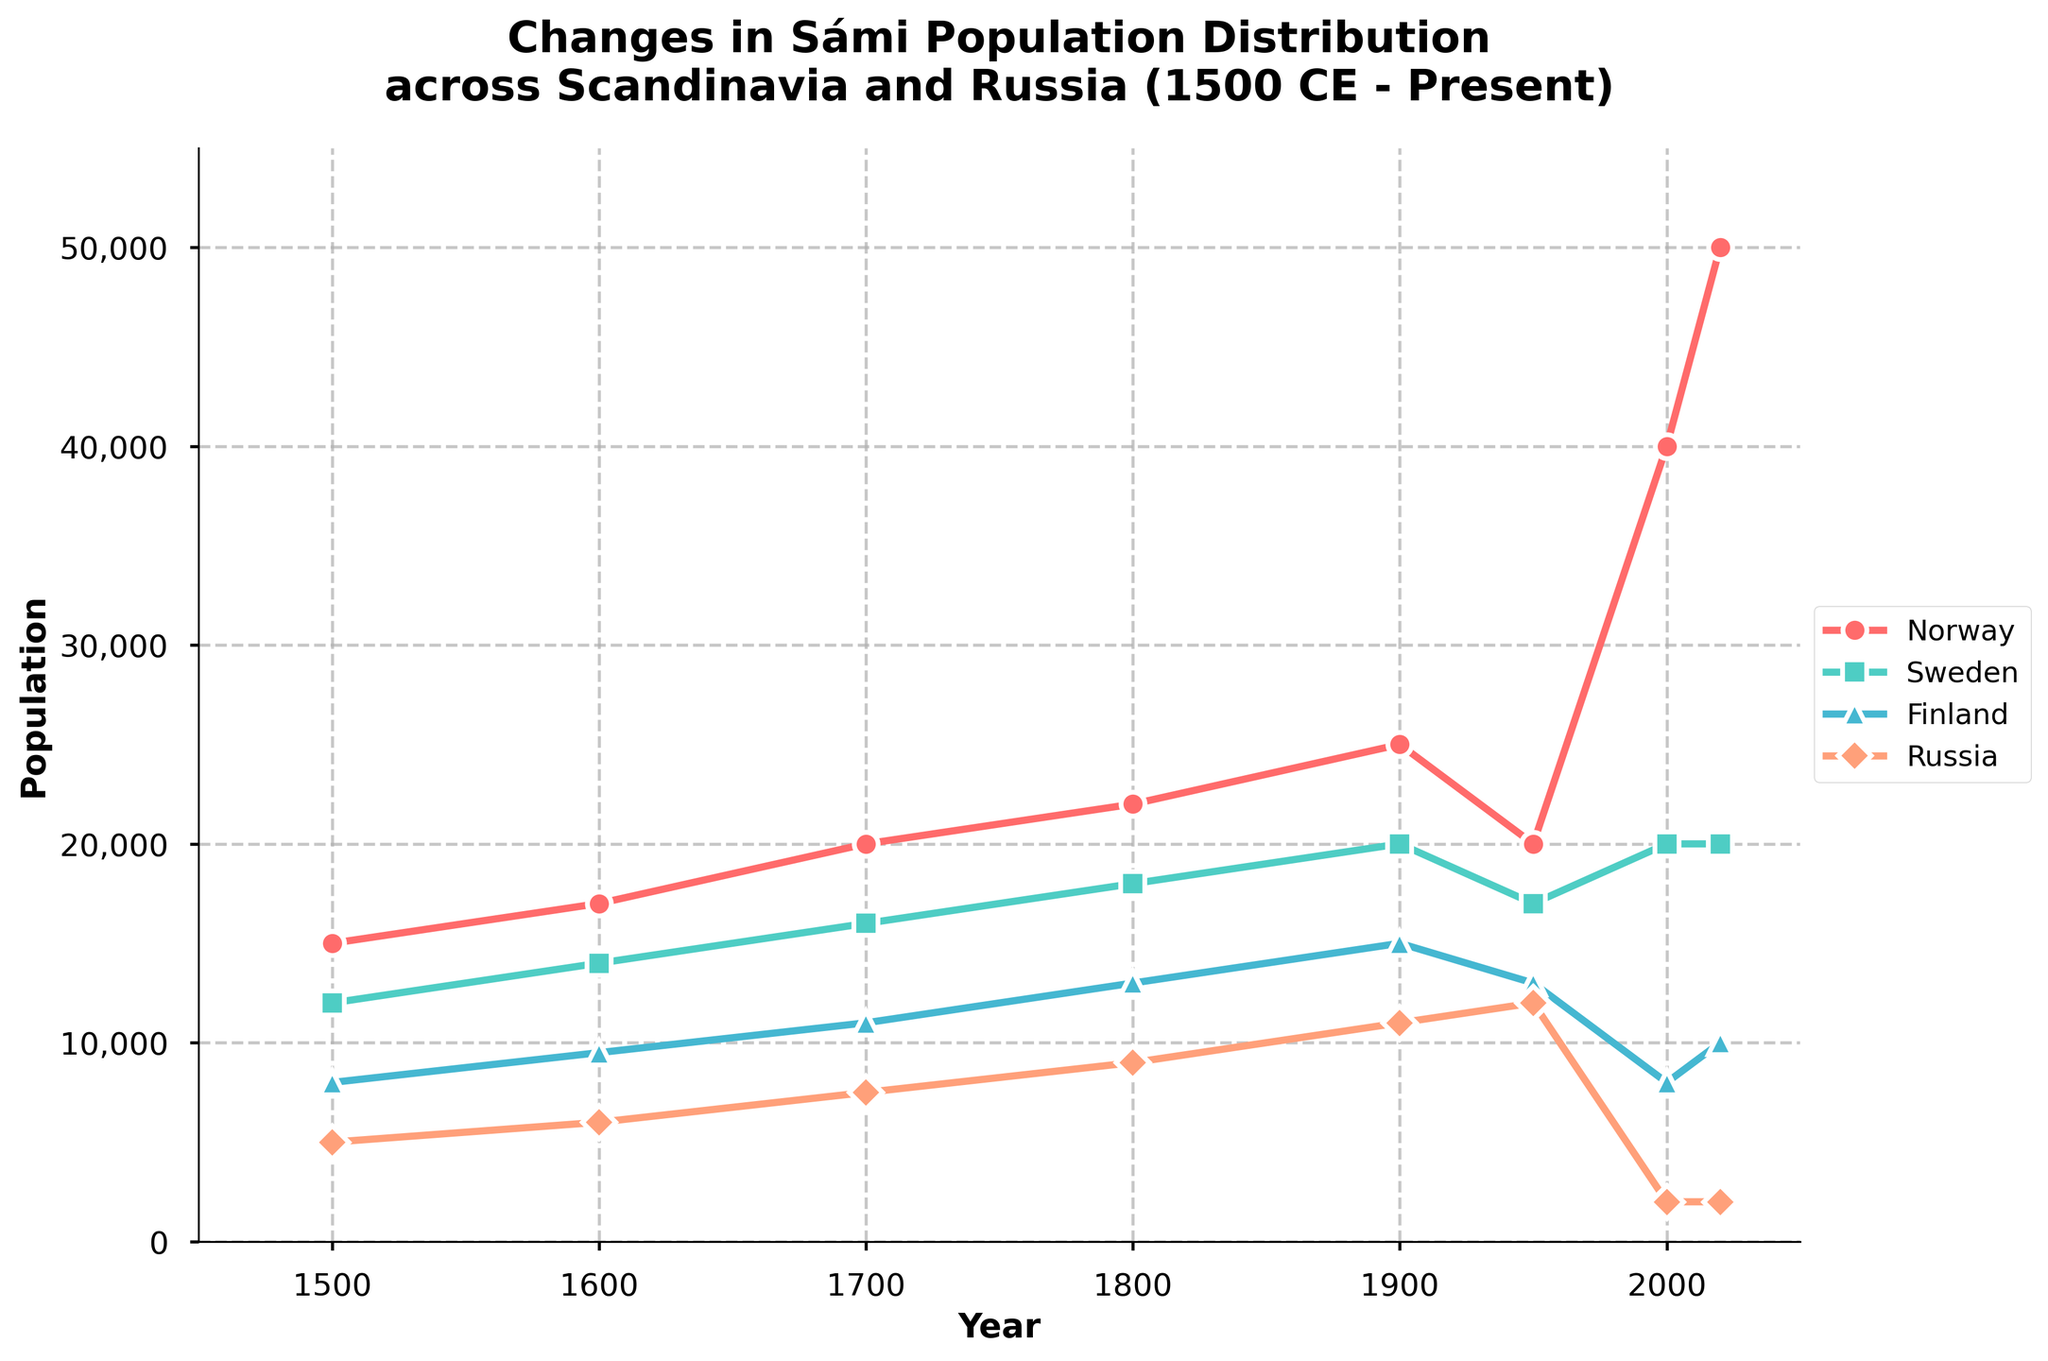What is the current Sámi population in Norway? To find the current Sámi population in Norway, look at the data point for the year 2020 along the line corresponding to Norway.
Answer: 50,000 In which year did Sweden and Russia have the same Sámi population? Identify the points where the lines representing Sweden and Russia intersect by looking for any overlapping markers.
Answer: 1950 Compare the trends of the Sámi populations in Finland and Russia from 1500 to 2020. Which country had a more significant population decrease? By looking at the slopes of the lines on the plot, you can see that the Russian line drops dramatically after 1950, while Finland's population decline is more gradual, especially from 1900 to 2000.
Answer: Russia Did the Sámi population in any country experience growth from 1950 to 2000? Observe the sections of the lines between these years for each country. Only Norway shows growth during this period.
Answer: Norway By how much did the Sámi population in Norway increase from 2000 to 2020? Look at the values for Norway in 2000 (40,000) and 2020 (50,000), and then subtract to find the difference. 50,000 - 40,000 = 10,000
Answer: 10,000 Which country had the highest Sámi population in 1700? Locate the values for each country at the year 1700 by looking at the corresponding markers and labels on the Y-axis. Norway has the highest value.
Answer: Norway What was the percentage decrease in the Sámi population in Sweden from 1950 to 2000? Find Sweden's population in 1950 (17,000) and 2000 (20,000). Calculate the percentage decrease: ((20,000 - 17,000) / 20,000) * 100
Answer: -15% Describe the overall trend in Finland's Sámi population from 1500 to 2020. Look at the line for Finland - it starts at 8,000 in 1500, increases to 15,000 by 1900, drops to 13,000 by 1950, and then decreases to 8,000 by 2000 and slightly rises to 10,000 by 2020. The overall trend shows a moderate increase followed by a decrease with some fluctuations.
Answer: Moderate increase then decrease Which country's Sámi population peaked in 1950 and then decreased? Observe the national lines and find which one has its highest point in 1950 and then drops. Sweden is the country with this pattern.
Answer: Sweden Which country had the least increase in Sámi population from 1500 to 1800? Compare the population changes of all countries from 1500 to 1800. Russia's population changed from 5,000 to 9,000, an increase of 4,000, which is the least among the countries.
Answer: Russia 